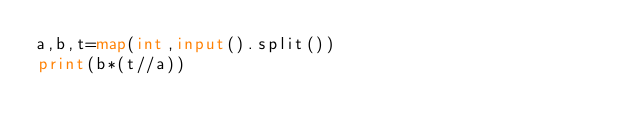<code> <loc_0><loc_0><loc_500><loc_500><_Python_>a,b,t=map(int,input().split())
print(b*(t//a))</code> 